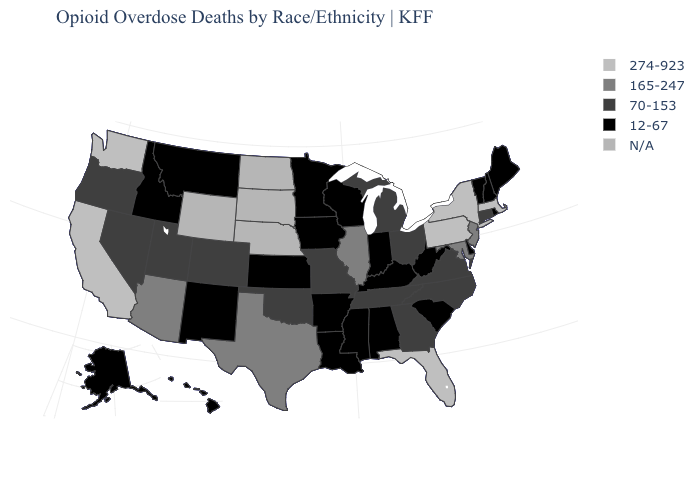Which states hav the highest value in the Northeast?
Keep it brief. Massachusetts, New York, Pennsylvania. Is the legend a continuous bar?
Keep it brief. No. Name the states that have a value in the range N/A?
Give a very brief answer. Nebraska, North Dakota, South Dakota, Wyoming. Name the states that have a value in the range 70-153?
Be succinct. Colorado, Connecticut, Georgia, Michigan, Missouri, Nevada, North Carolina, Ohio, Oklahoma, Oregon, Tennessee, Utah, Virginia. What is the lowest value in the USA?
Quick response, please. 12-67. Name the states that have a value in the range 274-923?
Be succinct. California, Florida, Massachusetts, New York, Pennsylvania, Washington. What is the value of Kentucky?
Give a very brief answer. 12-67. Does Michigan have the highest value in the MidWest?
Concise answer only. No. Which states have the lowest value in the MidWest?
Write a very short answer. Indiana, Iowa, Kansas, Minnesota, Wisconsin. What is the value of Pennsylvania?
Give a very brief answer. 274-923. What is the value of New York?
Write a very short answer. 274-923. Does the first symbol in the legend represent the smallest category?
Write a very short answer. No. What is the highest value in the USA?
Write a very short answer. 274-923. Name the states that have a value in the range N/A?
Be succinct. Nebraska, North Dakota, South Dakota, Wyoming. What is the highest value in the West ?
Keep it brief. 274-923. 